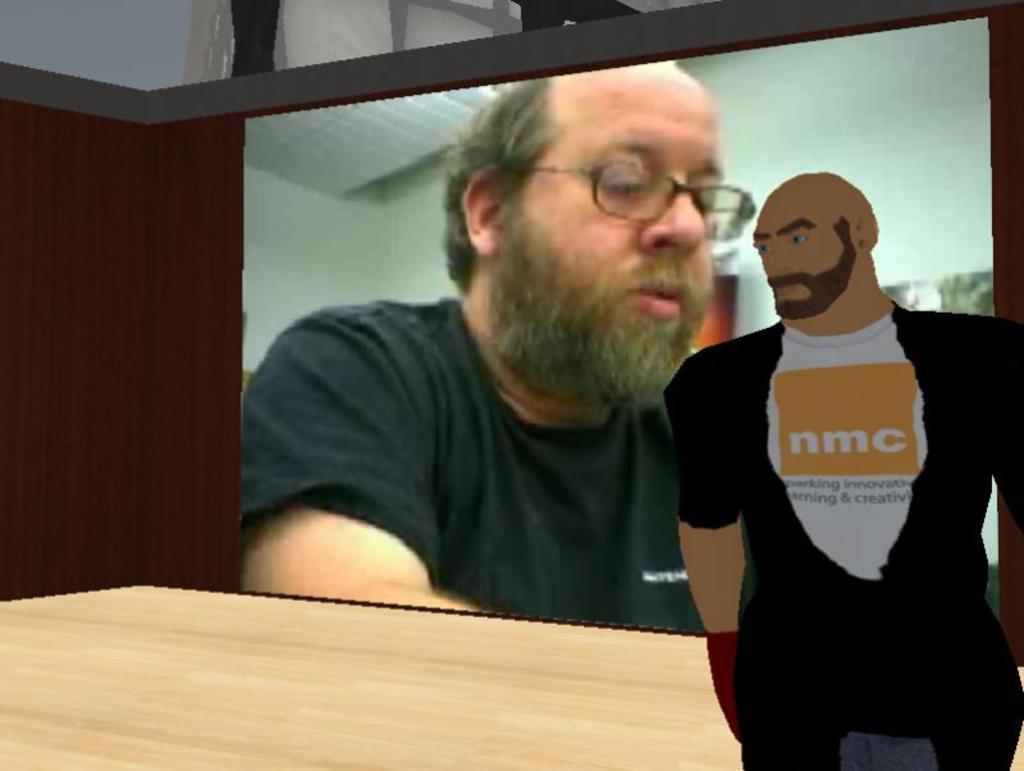Could you give a brief overview of what you see in this image? This is an edited image. Here we can see wall, floor, and a picture of a person. There is a screen. On the screen we can see a man. 